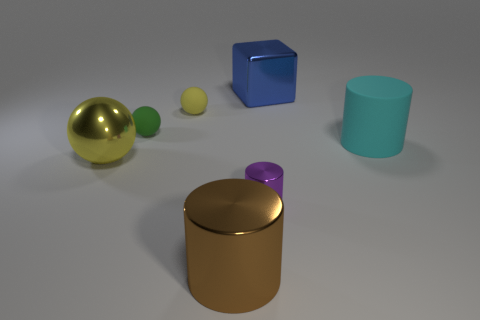Subtract all big metal cylinders. How many cylinders are left? 2 Add 1 small gray shiny spheres. How many objects exist? 8 Subtract all purple cylinders. How many cylinders are left? 2 Subtract all blocks. How many objects are left? 6 Subtract 1 cubes. How many cubes are left? 0 Subtract all yellow balls. Subtract all purple cylinders. How many balls are left? 1 Subtract all green cylinders. How many red balls are left? 0 Subtract all brown rubber spheres. Subtract all large yellow objects. How many objects are left? 6 Add 3 small green rubber objects. How many small green rubber objects are left? 4 Add 1 green rubber things. How many green rubber things exist? 2 